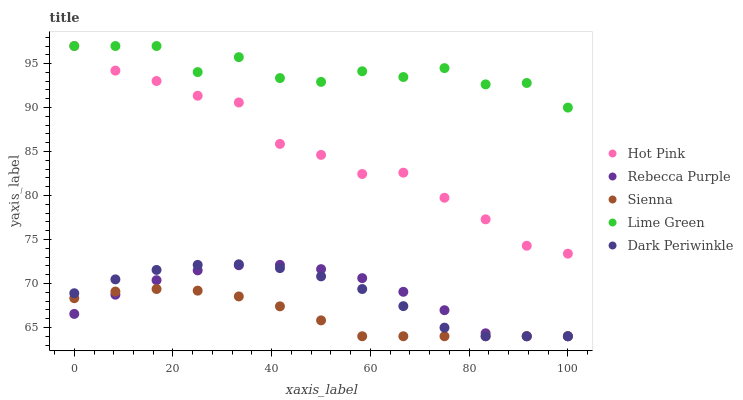Does Sienna have the minimum area under the curve?
Answer yes or no. Yes. Does Lime Green have the maximum area under the curve?
Answer yes or no. Yes. Does Hot Pink have the minimum area under the curve?
Answer yes or no. No. Does Hot Pink have the maximum area under the curve?
Answer yes or no. No. Is Sienna the smoothest?
Answer yes or no. Yes. Is Lime Green the roughest?
Answer yes or no. Yes. Is Hot Pink the smoothest?
Answer yes or no. No. Is Hot Pink the roughest?
Answer yes or no. No. Does Sienna have the lowest value?
Answer yes or no. Yes. Does Hot Pink have the lowest value?
Answer yes or no. No. Does Lime Green have the highest value?
Answer yes or no. Yes. Does Rebecca Purple have the highest value?
Answer yes or no. No. Is Rebecca Purple less than Lime Green?
Answer yes or no. Yes. Is Hot Pink greater than Dark Periwinkle?
Answer yes or no. Yes. Does Sienna intersect Rebecca Purple?
Answer yes or no. Yes. Is Sienna less than Rebecca Purple?
Answer yes or no. No. Is Sienna greater than Rebecca Purple?
Answer yes or no. No. Does Rebecca Purple intersect Lime Green?
Answer yes or no. No. 